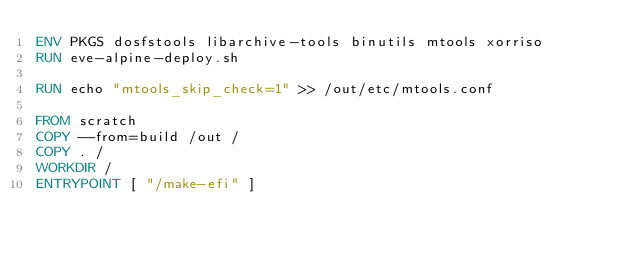<code> <loc_0><loc_0><loc_500><loc_500><_Dockerfile_>ENV PKGS dosfstools libarchive-tools binutils mtools xorriso
RUN eve-alpine-deploy.sh

RUN echo "mtools_skip_check=1" >> /out/etc/mtools.conf

FROM scratch
COPY --from=build /out /
COPY . /
WORKDIR /
ENTRYPOINT [ "/make-efi" ]
</code> 